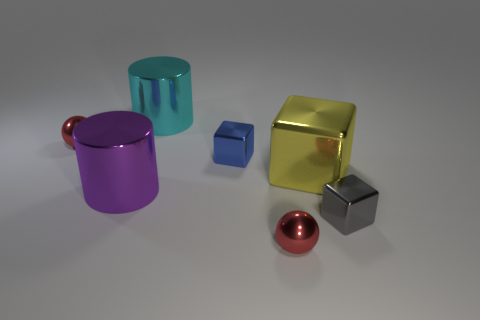Add 1 large gray rubber cylinders. How many objects exist? 8 Subtract all cylinders. How many objects are left? 5 Add 2 small red metallic things. How many small red metallic things exist? 4 Subtract 0 green cubes. How many objects are left? 7 Subtract all large green rubber cylinders. Subtract all shiny things. How many objects are left? 0 Add 1 small gray blocks. How many small gray blocks are left? 2 